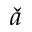<formula> <loc_0><loc_0><loc_500><loc_500>\check { a }</formula> 